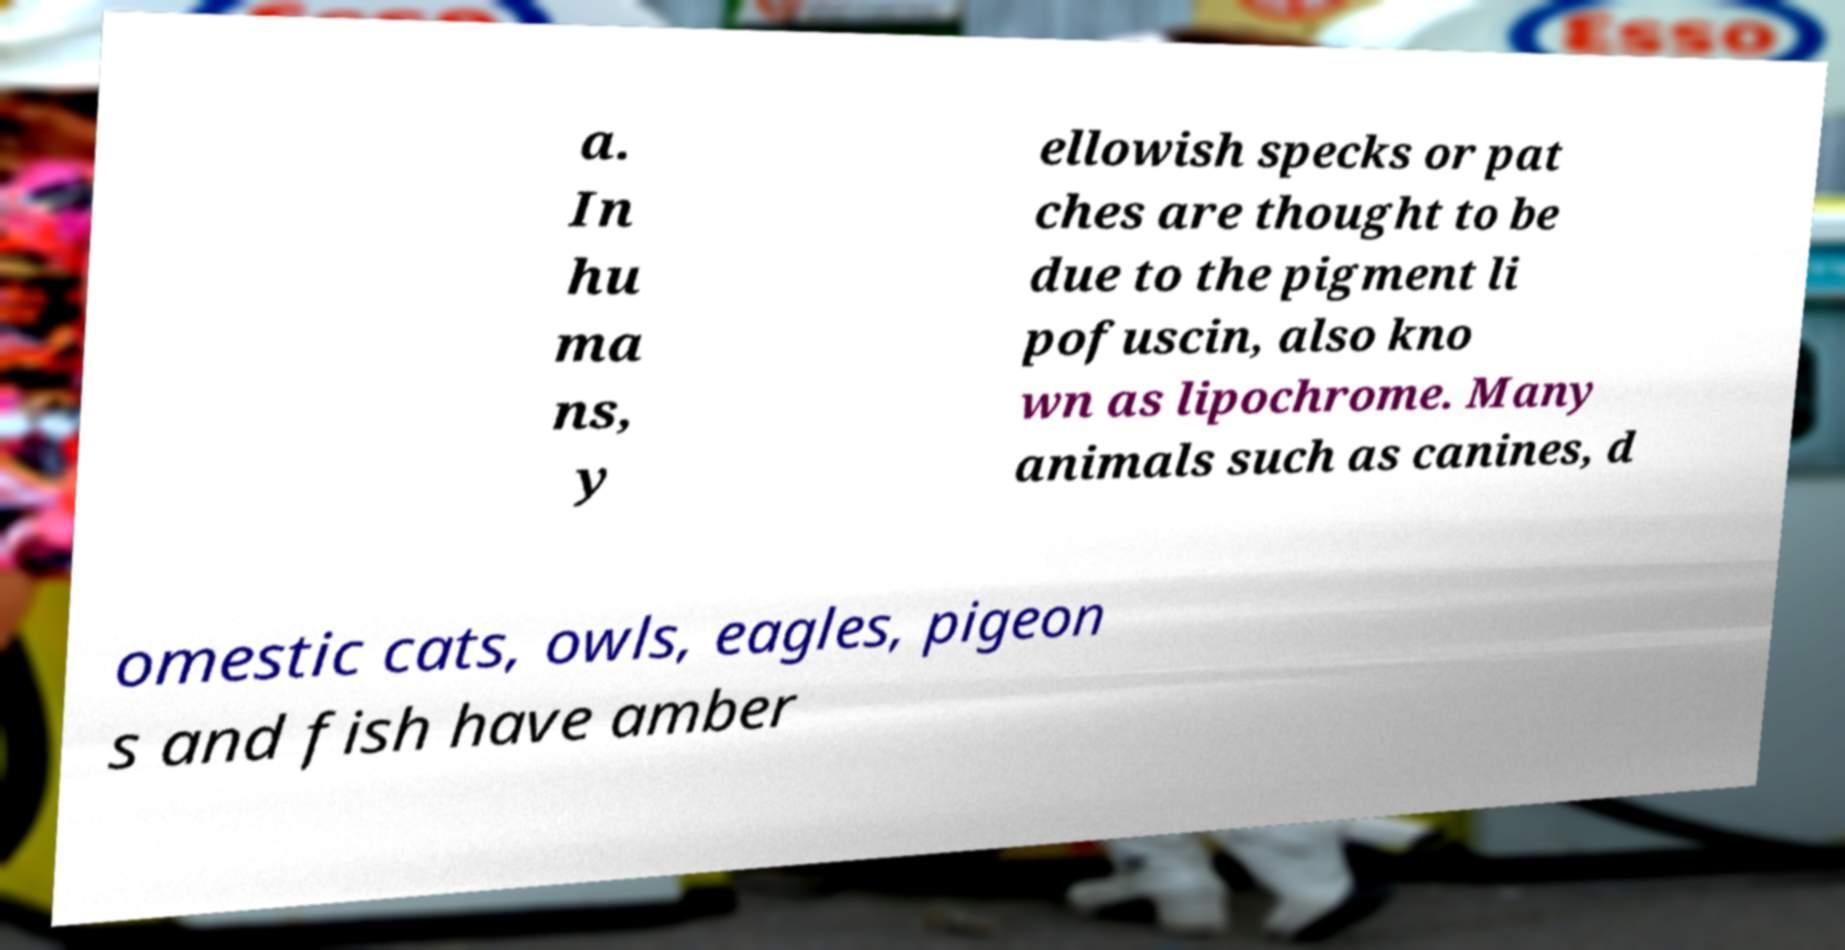Please read and relay the text visible in this image. What does it say? a. In hu ma ns, y ellowish specks or pat ches are thought to be due to the pigment li pofuscin, also kno wn as lipochrome. Many animals such as canines, d omestic cats, owls, eagles, pigeon s and fish have amber 